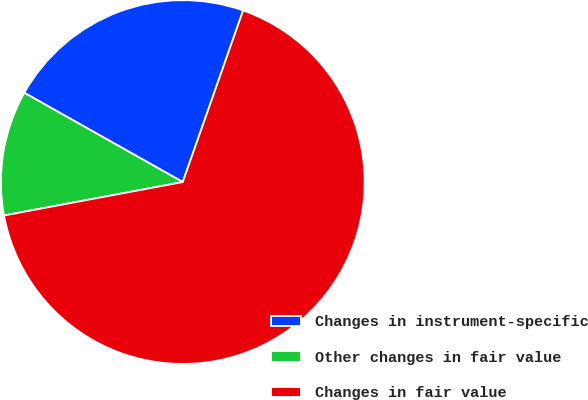<chart> <loc_0><loc_0><loc_500><loc_500><pie_chart><fcel>Changes in instrument-specific<fcel>Other changes in fair value<fcel>Changes in fair value<nl><fcel>22.22%<fcel>11.11%<fcel>66.67%<nl></chart> 